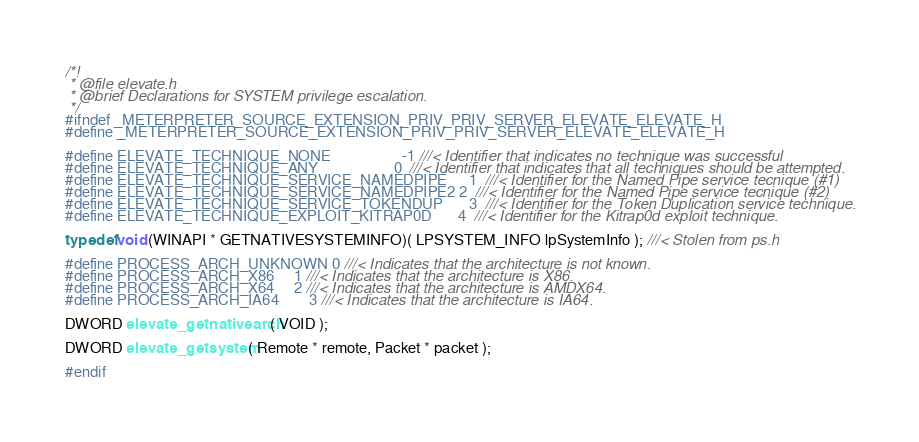Convert code to text. <code><loc_0><loc_0><loc_500><loc_500><_C_>/*!
 * @file elevate.h
 * @brief Declarations for SYSTEM privilege escalation.
 */
#ifndef _METERPRETER_SOURCE_EXTENSION_PRIV_PRIV_SERVER_ELEVATE_ELEVATE_H
#define _METERPRETER_SOURCE_EXTENSION_PRIV_PRIV_SERVER_ELEVATE_ELEVATE_H

#define ELEVATE_TECHNIQUE_NONE					-1 ///< Identifier that indicates no technique was successful
#define ELEVATE_TECHNIQUE_ANY					0  ///< Identifier that indicates that all techniques should be attempted.
#define ELEVATE_TECHNIQUE_SERVICE_NAMEDPIPE		1  ///< Identifier for the Named Pipe service tecnique (#1)
#define ELEVATE_TECHNIQUE_SERVICE_NAMEDPIPE2	2  ///< Identifier for the Named Pipe service tecnique (#2)
#define ELEVATE_TECHNIQUE_SERVICE_TOKENDUP		3  ///< Identifier for the Token Duplication service technique.
#define ELEVATE_TECHNIQUE_EXPLOIT_KITRAP0D		4  ///< Identifier for the Kitrap0d exploit technique.

typedef void (WINAPI * GETNATIVESYSTEMINFO)( LPSYSTEM_INFO lpSystemInfo ); ///< Stolen from ps.h

#define PROCESS_ARCH_UNKNOWN	0 ///< Indicates that the architecture is not known.
#define PROCESS_ARCH_X86		1 ///< Indicates that the architecture is X86.
#define PROCESS_ARCH_X64		2 ///< Indicates that the architecture is AMDX64.
#define PROCESS_ARCH_IA64		3 ///< Indicates that the architecture is IA64.

DWORD elevate_getnativearch( VOID );

DWORD elevate_getsystem( Remote * remote, Packet * packet );

#endif
</code> 